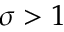Convert formula to latex. <formula><loc_0><loc_0><loc_500><loc_500>\sigma > 1</formula> 